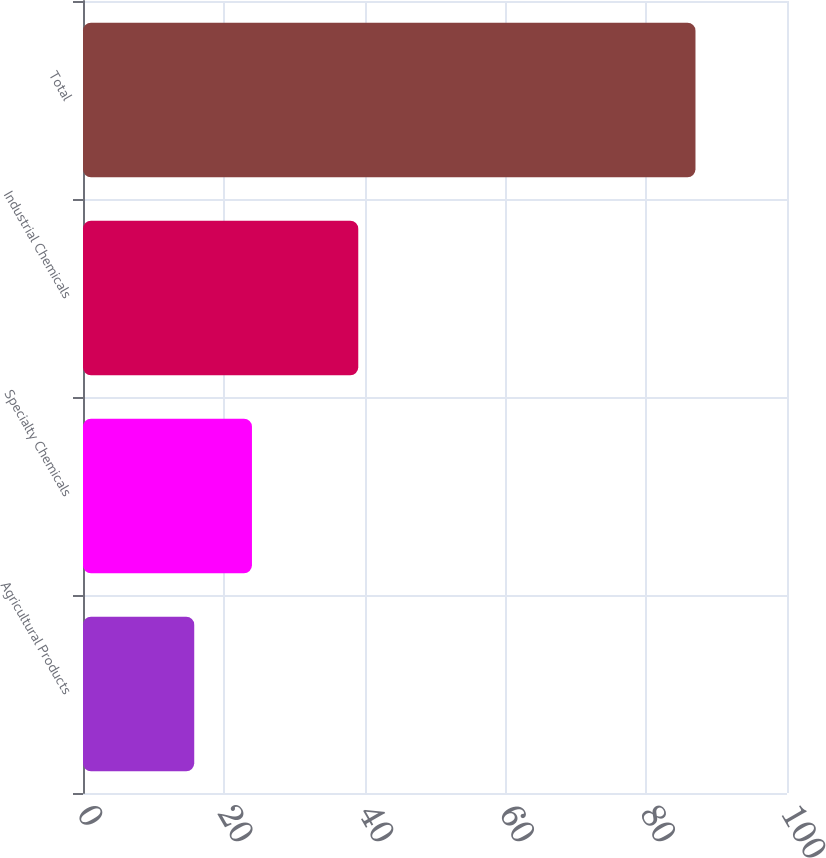Convert chart to OTSL. <chart><loc_0><loc_0><loc_500><loc_500><bar_chart><fcel>Agricultural Products<fcel>Specialty Chemicals<fcel>Industrial Chemicals<fcel>Total<nl><fcel>15.8<fcel>24<fcel>39.1<fcel>87<nl></chart> 